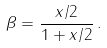<formula> <loc_0><loc_0><loc_500><loc_500>\beta = \frac { x / 2 } { 1 + x / 2 } \, .</formula> 